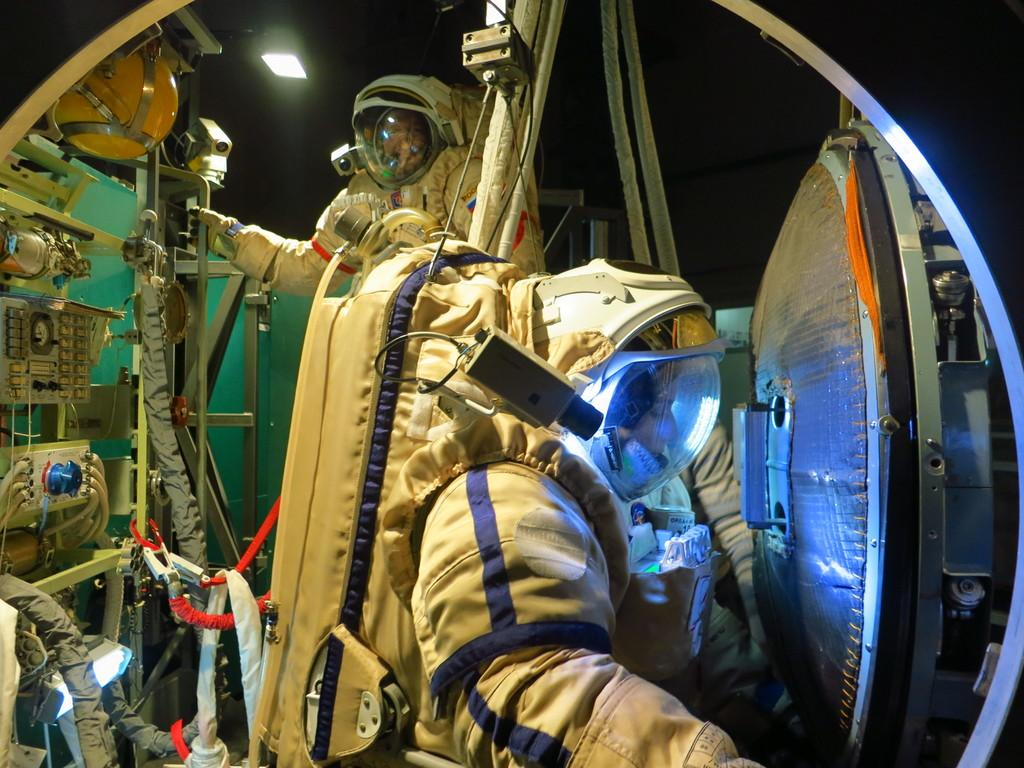How many people are in the image? There are two persons in the image. What are the persons wearing? The persons are wearing astronaut dresses. What colors are the astronaut dresses? The astronaut dresses are cream and blue in color. What else can be seen in the image besides the persons? There are other equipment visible in the image. Can you describe the lighting in the image? There is a light in the image. What is the color of the background in the image? The background of the image is dark. What type of basket is being used to transport the astronauts in the image? There is no basket present in the image; the persons are wearing astronaut dresses. How do the astronauts apply the brake while wearing their dresses in the image? The astronauts do not apply any brakes in the image; they are not in a vehicle or any situation that requires braking. 